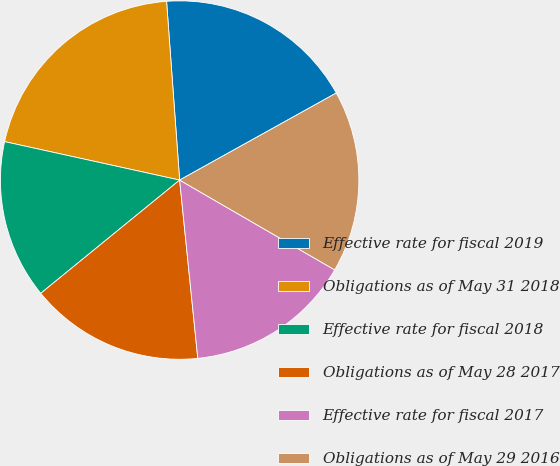Convert chart to OTSL. <chart><loc_0><loc_0><loc_500><loc_500><pie_chart><fcel>Effective rate for fiscal 2019<fcel>Obligations as of May 31 2018<fcel>Effective rate for fiscal 2018<fcel>Obligations as of May 28 2017<fcel>Effective rate for fiscal 2017<fcel>Obligations as of May 29 2016<nl><fcel>18.09%<fcel>20.4%<fcel>14.33%<fcel>15.73%<fcel>15.03%<fcel>16.43%<nl></chart> 